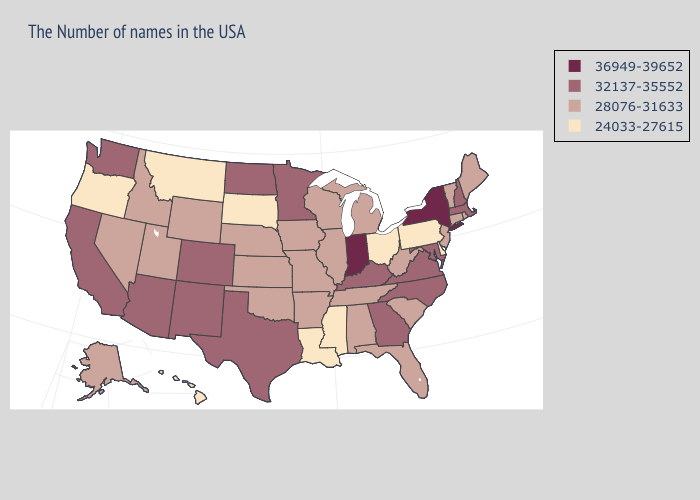What is the value of Ohio?
Keep it brief. 24033-27615. Name the states that have a value in the range 32137-35552?
Answer briefly. Massachusetts, New Hampshire, Maryland, Virginia, North Carolina, Georgia, Kentucky, Minnesota, Texas, North Dakota, Colorado, New Mexico, Arizona, California, Washington. Does the first symbol in the legend represent the smallest category?
Write a very short answer. No. What is the highest value in the USA?
Be succinct. 36949-39652. What is the lowest value in states that border Wyoming?
Be succinct. 24033-27615. Does New York have the highest value in the USA?
Concise answer only. Yes. What is the value of Ohio?
Answer briefly. 24033-27615. What is the value of North Dakota?
Give a very brief answer. 32137-35552. What is the value of Washington?
Give a very brief answer. 32137-35552. Is the legend a continuous bar?
Short answer required. No. Does Ohio have the highest value in the USA?
Concise answer only. No. Among the states that border Arizona , does Colorado have the lowest value?
Quick response, please. No. Name the states that have a value in the range 32137-35552?
Write a very short answer. Massachusetts, New Hampshire, Maryland, Virginia, North Carolina, Georgia, Kentucky, Minnesota, Texas, North Dakota, Colorado, New Mexico, Arizona, California, Washington. Name the states that have a value in the range 28076-31633?
Short answer required. Maine, Rhode Island, Vermont, Connecticut, New Jersey, South Carolina, West Virginia, Florida, Michigan, Alabama, Tennessee, Wisconsin, Illinois, Missouri, Arkansas, Iowa, Kansas, Nebraska, Oklahoma, Wyoming, Utah, Idaho, Nevada, Alaska. Does New Mexico have a higher value than Maine?
Keep it brief. Yes. 